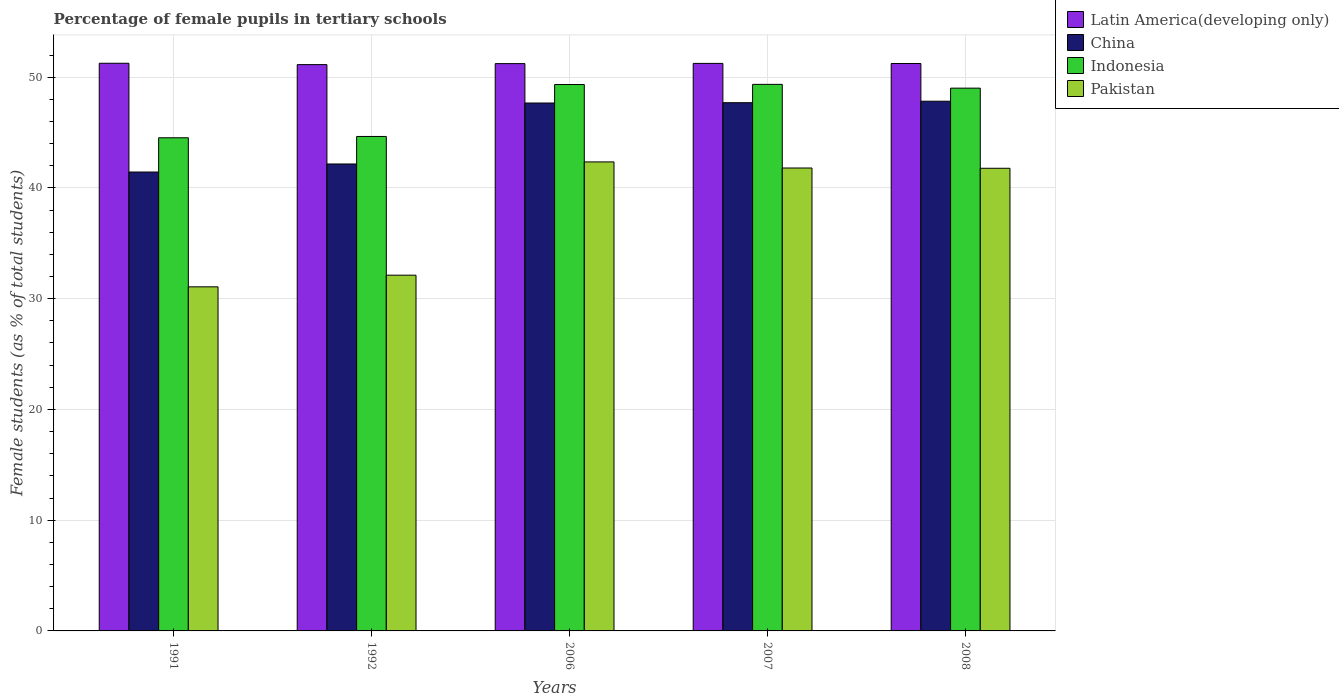How many different coloured bars are there?
Give a very brief answer. 4. How many bars are there on the 4th tick from the right?
Offer a very short reply. 4. What is the label of the 2nd group of bars from the left?
Provide a short and direct response. 1992. In how many cases, is the number of bars for a given year not equal to the number of legend labels?
Your answer should be very brief. 0. What is the percentage of female pupils in tertiary schools in Indonesia in 2008?
Offer a terse response. 49.01. Across all years, what is the maximum percentage of female pupils in tertiary schools in Indonesia?
Your answer should be compact. 49.35. Across all years, what is the minimum percentage of female pupils in tertiary schools in Indonesia?
Provide a short and direct response. 44.53. In which year was the percentage of female pupils in tertiary schools in China maximum?
Keep it short and to the point. 2008. What is the total percentage of female pupils in tertiary schools in Latin America(developing only) in the graph?
Your response must be concise. 256.1. What is the difference between the percentage of female pupils in tertiary schools in Pakistan in 1992 and that in 2007?
Offer a very short reply. -9.68. What is the difference between the percentage of female pupils in tertiary schools in China in 2007 and the percentage of female pupils in tertiary schools in Pakistan in 1991?
Ensure brevity in your answer.  16.63. What is the average percentage of female pupils in tertiary schools in Latin America(developing only) per year?
Provide a short and direct response. 51.22. In the year 1992, what is the difference between the percentage of female pupils in tertiary schools in China and percentage of female pupils in tertiary schools in Indonesia?
Your response must be concise. -2.49. What is the ratio of the percentage of female pupils in tertiary schools in Latin America(developing only) in 1991 to that in 1992?
Keep it short and to the point. 1. Is the percentage of female pupils in tertiary schools in Latin America(developing only) in 1991 less than that in 2006?
Offer a very short reply. No. Is the difference between the percentage of female pupils in tertiary schools in China in 1991 and 2006 greater than the difference between the percentage of female pupils in tertiary schools in Indonesia in 1991 and 2006?
Keep it short and to the point. No. What is the difference between the highest and the second highest percentage of female pupils in tertiary schools in Indonesia?
Provide a succinct answer. 0.01. What is the difference between the highest and the lowest percentage of female pupils in tertiary schools in Pakistan?
Keep it short and to the point. 11.28. Is the sum of the percentage of female pupils in tertiary schools in Pakistan in 1992 and 2008 greater than the maximum percentage of female pupils in tertiary schools in Indonesia across all years?
Keep it short and to the point. Yes. Are all the bars in the graph horizontal?
Your response must be concise. No. How many years are there in the graph?
Your answer should be very brief. 5. What is the difference between two consecutive major ticks on the Y-axis?
Provide a short and direct response. 10. Are the values on the major ticks of Y-axis written in scientific E-notation?
Provide a short and direct response. No. Does the graph contain grids?
Offer a terse response. Yes. How many legend labels are there?
Your answer should be compact. 4. What is the title of the graph?
Give a very brief answer. Percentage of female pupils in tertiary schools. Does "Central African Republic" appear as one of the legend labels in the graph?
Offer a very short reply. No. What is the label or title of the X-axis?
Provide a short and direct response. Years. What is the label or title of the Y-axis?
Offer a terse response. Female students (as % of total students). What is the Female students (as % of total students) of Latin America(developing only) in 1991?
Provide a succinct answer. 51.26. What is the Female students (as % of total students) of China in 1991?
Make the answer very short. 41.44. What is the Female students (as % of total students) in Indonesia in 1991?
Your answer should be very brief. 44.53. What is the Female students (as % of total students) in Pakistan in 1991?
Offer a terse response. 31.07. What is the Female students (as % of total students) of Latin America(developing only) in 1992?
Give a very brief answer. 51.13. What is the Female students (as % of total students) in China in 1992?
Offer a terse response. 42.16. What is the Female students (as % of total students) in Indonesia in 1992?
Offer a very short reply. 44.65. What is the Female students (as % of total students) of Pakistan in 1992?
Keep it short and to the point. 32.12. What is the Female students (as % of total students) in Latin America(developing only) in 2006?
Provide a succinct answer. 51.22. What is the Female students (as % of total students) of China in 2006?
Give a very brief answer. 47.67. What is the Female students (as % of total students) of Indonesia in 2006?
Keep it short and to the point. 49.34. What is the Female students (as % of total students) of Pakistan in 2006?
Provide a short and direct response. 42.35. What is the Female students (as % of total students) of Latin America(developing only) in 2007?
Provide a succinct answer. 51.24. What is the Female students (as % of total students) in China in 2007?
Ensure brevity in your answer.  47.7. What is the Female students (as % of total students) in Indonesia in 2007?
Ensure brevity in your answer.  49.35. What is the Female students (as % of total students) in Pakistan in 2007?
Your answer should be compact. 41.8. What is the Female students (as % of total students) of Latin America(developing only) in 2008?
Provide a succinct answer. 51.24. What is the Female students (as % of total students) in China in 2008?
Your answer should be very brief. 47.83. What is the Female students (as % of total students) of Indonesia in 2008?
Keep it short and to the point. 49.01. What is the Female students (as % of total students) in Pakistan in 2008?
Offer a very short reply. 41.78. Across all years, what is the maximum Female students (as % of total students) of Latin America(developing only)?
Provide a short and direct response. 51.26. Across all years, what is the maximum Female students (as % of total students) in China?
Offer a terse response. 47.83. Across all years, what is the maximum Female students (as % of total students) of Indonesia?
Offer a terse response. 49.35. Across all years, what is the maximum Female students (as % of total students) in Pakistan?
Provide a succinct answer. 42.35. Across all years, what is the minimum Female students (as % of total students) in Latin America(developing only)?
Keep it short and to the point. 51.13. Across all years, what is the minimum Female students (as % of total students) of China?
Your answer should be compact. 41.44. Across all years, what is the minimum Female students (as % of total students) of Indonesia?
Provide a succinct answer. 44.53. Across all years, what is the minimum Female students (as % of total students) in Pakistan?
Offer a very short reply. 31.07. What is the total Female students (as % of total students) of Latin America(developing only) in the graph?
Make the answer very short. 256.1. What is the total Female students (as % of total students) of China in the graph?
Your response must be concise. 226.79. What is the total Female students (as % of total students) of Indonesia in the graph?
Provide a succinct answer. 236.87. What is the total Female students (as % of total students) of Pakistan in the graph?
Your response must be concise. 189.11. What is the difference between the Female students (as % of total students) of Latin America(developing only) in 1991 and that in 1992?
Make the answer very short. 0.12. What is the difference between the Female students (as % of total students) of China in 1991 and that in 1992?
Give a very brief answer. -0.73. What is the difference between the Female students (as % of total students) in Indonesia in 1991 and that in 1992?
Your response must be concise. -0.12. What is the difference between the Female students (as % of total students) of Pakistan in 1991 and that in 1992?
Offer a terse response. -1.05. What is the difference between the Female students (as % of total students) of Latin America(developing only) in 1991 and that in 2006?
Offer a terse response. 0.03. What is the difference between the Female students (as % of total students) in China in 1991 and that in 2006?
Your answer should be very brief. -6.23. What is the difference between the Female students (as % of total students) of Indonesia in 1991 and that in 2006?
Your answer should be very brief. -4.81. What is the difference between the Female students (as % of total students) of Pakistan in 1991 and that in 2006?
Offer a very short reply. -11.28. What is the difference between the Female students (as % of total students) in Latin America(developing only) in 1991 and that in 2007?
Ensure brevity in your answer.  0.01. What is the difference between the Female students (as % of total students) in China in 1991 and that in 2007?
Give a very brief answer. -6.26. What is the difference between the Female students (as % of total students) in Indonesia in 1991 and that in 2007?
Keep it short and to the point. -4.82. What is the difference between the Female students (as % of total students) in Pakistan in 1991 and that in 2007?
Offer a very short reply. -10.73. What is the difference between the Female students (as % of total students) in Latin America(developing only) in 1991 and that in 2008?
Make the answer very short. 0.02. What is the difference between the Female students (as % of total students) of China in 1991 and that in 2008?
Offer a very short reply. -6.39. What is the difference between the Female students (as % of total students) in Indonesia in 1991 and that in 2008?
Offer a very short reply. -4.48. What is the difference between the Female students (as % of total students) in Pakistan in 1991 and that in 2008?
Provide a succinct answer. -10.71. What is the difference between the Female students (as % of total students) in Latin America(developing only) in 1992 and that in 2006?
Give a very brief answer. -0.09. What is the difference between the Female students (as % of total students) in China in 1992 and that in 2006?
Provide a short and direct response. -5.51. What is the difference between the Female students (as % of total students) of Indonesia in 1992 and that in 2006?
Offer a terse response. -4.69. What is the difference between the Female students (as % of total students) of Pakistan in 1992 and that in 2006?
Provide a short and direct response. -10.23. What is the difference between the Female students (as % of total students) of Latin America(developing only) in 1992 and that in 2007?
Offer a very short reply. -0.11. What is the difference between the Female students (as % of total students) of China in 1992 and that in 2007?
Offer a terse response. -5.53. What is the difference between the Female students (as % of total students) of Indonesia in 1992 and that in 2007?
Offer a very short reply. -4.7. What is the difference between the Female students (as % of total students) in Pakistan in 1992 and that in 2007?
Provide a short and direct response. -9.68. What is the difference between the Female students (as % of total students) in Latin America(developing only) in 1992 and that in 2008?
Give a very brief answer. -0.1. What is the difference between the Female students (as % of total students) of China in 1992 and that in 2008?
Give a very brief answer. -5.67. What is the difference between the Female students (as % of total students) in Indonesia in 1992 and that in 2008?
Give a very brief answer. -4.36. What is the difference between the Female students (as % of total students) of Pakistan in 1992 and that in 2008?
Offer a terse response. -9.65. What is the difference between the Female students (as % of total students) of Latin America(developing only) in 2006 and that in 2007?
Ensure brevity in your answer.  -0.02. What is the difference between the Female students (as % of total students) of China in 2006 and that in 2007?
Keep it short and to the point. -0.03. What is the difference between the Female students (as % of total students) in Indonesia in 2006 and that in 2007?
Offer a terse response. -0.01. What is the difference between the Female students (as % of total students) in Pakistan in 2006 and that in 2007?
Offer a terse response. 0.55. What is the difference between the Female students (as % of total students) of Latin America(developing only) in 2006 and that in 2008?
Keep it short and to the point. -0.01. What is the difference between the Female students (as % of total students) in China in 2006 and that in 2008?
Offer a very short reply. -0.16. What is the difference between the Female students (as % of total students) in Indonesia in 2006 and that in 2008?
Your answer should be very brief. 0.33. What is the difference between the Female students (as % of total students) in Pakistan in 2006 and that in 2008?
Ensure brevity in your answer.  0.57. What is the difference between the Female students (as % of total students) of Latin America(developing only) in 2007 and that in 2008?
Provide a short and direct response. 0.01. What is the difference between the Female students (as % of total students) of China in 2007 and that in 2008?
Offer a very short reply. -0.13. What is the difference between the Female students (as % of total students) in Indonesia in 2007 and that in 2008?
Provide a short and direct response. 0.34. What is the difference between the Female students (as % of total students) of Pakistan in 2007 and that in 2008?
Keep it short and to the point. 0.02. What is the difference between the Female students (as % of total students) of Latin America(developing only) in 1991 and the Female students (as % of total students) of China in 1992?
Provide a short and direct response. 9.09. What is the difference between the Female students (as % of total students) of Latin America(developing only) in 1991 and the Female students (as % of total students) of Indonesia in 1992?
Your answer should be compact. 6.61. What is the difference between the Female students (as % of total students) of Latin America(developing only) in 1991 and the Female students (as % of total students) of Pakistan in 1992?
Your answer should be very brief. 19.14. What is the difference between the Female students (as % of total students) in China in 1991 and the Female students (as % of total students) in Indonesia in 1992?
Ensure brevity in your answer.  -3.21. What is the difference between the Female students (as % of total students) of China in 1991 and the Female students (as % of total students) of Pakistan in 1992?
Provide a succinct answer. 9.31. What is the difference between the Female students (as % of total students) of Indonesia in 1991 and the Female students (as % of total students) of Pakistan in 1992?
Provide a short and direct response. 12.41. What is the difference between the Female students (as % of total students) in Latin America(developing only) in 1991 and the Female students (as % of total students) in China in 2006?
Provide a succinct answer. 3.59. What is the difference between the Female students (as % of total students) in Latin America(developing only) in 1991 and the Female students (as % of total students) in Indonesia in 2006?
Make the answer very short. 1.92. What is the difference between the Female students (as % of total students) of Latin America(developing only) in 1991 and the Female students (as % of total students) of Pakistan in 2006?
Ensure brevity in your answer.  8.91. What is the difference between the Female students (as % of total students) in China in 1991 and the Female students (as % of total students) in Indonesia in 2006?
Ensure brevity in your answer.  -7.9. What is the difference between the Female students (as % of total students) of China in 1991 and the Female students (as % of total students) of Pakistan in 2006?
Provide a short and direct response. -0.91. What is the difference between the Female students (as % of total students) of Indonesia in 1991 and the Female students (as % of total students) of Pakistan in 2006?
Provide a succinct answer. 2.18. What is the difference between the Female students (as % of total students) of Latin America(developing only) in 1991 and the Female students (as % of total students) of China in 2007?
Provide a succinct answer. 3.56. What is the difference between the Female students (as % of total students) in Latin America(developing only) in 1991 and the Female students (as % of total students) in Indonesia in 2007?
Ensure brevity in your answer.  1.91. What is the difference between the Female students (as % of total students) of Latin America(developing only) in 1991 and the Female students (as % of total students) of Pakistan in 2007?
Offer a terse response. 9.46. What is the difference between the Female students (as % of total students) of China in 1991 and the Female students (as % of total students) of Indonesia in 2007?
Your answer should be very brief. -7.91. What is the difference between the Female students (as % of total students) in China in 1991 and the Female students (as % of total students) in Pakistan in 2007?
Your answer should be compact. -0.36. What is the difference between the Female students (as % of total students) of Indonesia in 1991 and the Female students (as % of total students) of Pakistan in 2007?
Your answer should be very brief. 2.73. What is the difference between the Female students (as % of total students) of Latin America(developing only) in 1991 and the Female students (as % of total students) of China in 2008?
Provide a succinct answer. 3.43. What is the difference between the Female students (as % of total students) in Latin America(developing only) in 1991 and the Female students (as % of total students) in Indonesia in 2008?
Give a very brief answer. 2.25. What is the difference between the Female students (as % of total students) in Latin America(developing only) in 1991 and the Female students (as % of total students) in Pakistan in 2008?
Ensure brevity in your answer.  9.48. What is the difference between the Female students (as % of total students) of China in 1991 and the Female students (as % of total students) of Indonesia in 2008?
Ensure brevity in your answer.  -7.57. What is the difference between the Female students (as % of total students) of China in 1991 and the Female students (as % of total students) of Pakistan in 2008?
Offer a terse response. -0.34. What is the difference between the Female students (as % of total students) of Indonesia in 1991 and the Female students (as % of total students) of Pakistan in 2008?
Make the answer very short. 2.75. What is the difference between the Female students (as % of total students) in Latin America(developing only) in 1992 and the Female students (as % of total students) in China in 2006?
Ensure brevity in your answer.  3.47. What is the difference between the Female students (as % of total students) of Latin America(developing only) in 1992 and the Female students (as % of total students) of Indonesia in 2006?
Make the answer very short. 1.8. What is the difference between the Female students (as % of total students) in Latin America(developing only) in 1992 and the Female students (as % of total students) in Pakistan in 2006?
Ensure brevity in your answer.  8.78. What is the difference between the Female students (as % of total students) of China in 1992 and the Female students (as % of total students) of Indonesia in 2006?
Provide a short and direct response. -7.17. What is the difference between the Female students (as % of total students) in China in 1992 and the Female students (as % of total students) in Pakistan in 2006?
Give a very brief answer. -0.19. What is the difference between the Female students (as % of total students) of Indonesia in 1992 and the Female students (as % of total students) of Pakistan in 2006?
Your response must be concise. 2.3. What is the difference between the Female students (as % of total students) of Latin America(developing only) in 1992 and the Female students (as % of total students) of China in 2007?
Make the answer very short. 3.44. What is the difference between the Female students (as % of total students) in Latin America(developing only) in 1992 and the Female students (as % of total students) in Indonesia in 2007?
Your answer should be very brief. 1.78. What is the difference between the Female students (as % of total students) in Latin America(developing only) in 1992 and the Female students (as % of total students) in Pakistan in 2007?
Your response must be concise. 9.34. What is the difference between the Female students (as % of total students) of China in 1992 and the Female students (as % of total students) of Indonesia in 2007?
Keep it short and to the point. -7.19. What is the difference between the Female students (as % of total students) in China in 1992 and the Female students (as % of total students) in Pakistan in 2007?
Keep it short and to the point. 0.36. What is the difference between the Female students (as % of total students) of Indonesia in 1992 and the Female students (as % of total students) of Pakistan in 2007?
Make the answer very short. 2.85. What is the difference between the Female students (as % of total students) in Latin America(developing only) in 1992 and the Female students (as % of total students) in China in 2008?
Your answer should be compact. 3.3. What is the difference between the Female students (as % of total students) in Latin America(developing only) in 1992 and the Female students (as % of total students) in Indonesia in 2008?
Provide a succinct answer. 2.12. What is the difference between the Female students (as % of total students) in Latin America(developing only) in 1992 and the Female students (as % of total students) in Pakistan in 2008?
Offer a terse response. 9.36. What is the difference between the Female students (as % of total students) of China in 1992 and the Female students (as % of total students) of Indonesia in 2008?
Make the answer very short. -6.85. What is the difference between the Female students (as % of total students) in China in 1992 and the Female students (as % of total students) in Pakistan in 2008?
Ensure brevity in your answer.  0.39. What is the difference between the Female students (as % of total students) in Indonesia in 1992 and the Female students (as % of total students) in Pakistan in 2008?
Make the answer very short. 2.87. What is the difference between the Female students (as % of total students) in Latin America(developing only) in 2006 and the Female students (as % of total students) in China in 2007?
Your answer should be very brief. 3.53. What is the difference between the Female students (as % of total students) in Latin America(developing only) in 2006 and the Female students (as % of total students) in Indonesia in 2007?
Make the answer very short. 1.87. What is the difference between the Female students (as % of total students) in Latin America(developing only) in 2006 and the Female students (as % of total students) in Pakistan in 2007?
Keep it short and to the point. 9.43. What is the difference between the Female students (as % of total students) of China in 2006 and the Female students (as % of total students) of Indonesia in 2007?
Make the answer very short. -1.68. What is the difference between the Female students (as % of total students) in China in 2006 and the Female students (as % of total students) in Pakistan in 2007?
Keep it short and to the point. 5.87. What is the difference between the Female students (as % of total students) of Indonesia in 2006 and the Female students (as % of total students) of Pakistan in 2007?
Ensure brevity in your answer.  7.54. What is the difference between the Female students (as % of total students) of Latin America(developing only) in 2006 and the Female students (as % of total students) of China in 2008?
Your response must be concise. 3.39. What is the difference between the Female students (as % of total students) of Latin America(developing only) in 2006 and the Female students (as % of total students) of Indonesia in 2008?
Offer a very short reply. 2.21. What is the difference between the Female students (as % of total students) of Latin America(developing only) in 2006 and the Female students (as % of total students) of Pakistan in 2008?
Offer a very short reply. 9.45. What is the difference between the Female students (as % of total students) in China in 2006 and the Female students (as % of total students) in Indonesia in 2008?
Provide a succinct answer. -1.34. What is the difference between the Female students (as % of total students) in China in 2006 and the Female students (as % of total students) in Pakistan in 2008?
Provide a succinct answer. 5.89. What is the difference between the Female students (as % of total students) in Indonesia in 2006 and the Female students (as % of total students) in Pakistan in 2008?
Keep it short and to the point. 7.56. What is the difference between the Female students (as % of total students) of Latin America(developing only) in 2007 and the Female students (as % of total students) of China in 2008?
Your answer should be very brief. 3.41. What is the difference between the Female students (as % of total students) in Latin America(developing only) in 2007 and the Female students (as % of total students) in Indonesia in 2008?
Give a very brief answer. 2.24. What is the difference between the Female students (as % of total students) in Latin America(developing only) in 2007 and the Female students (as % of total students) in Pakistan in 2008?
Keep it short and to the point. 9.47. What is the difference between the Female students (as % of total students) in China in 2007 and the Female students (as % of total students) in Indonesia in 2008?
Offer a terse response. -1.31. What is the difference between the Female students (as % of total students) in China in 2007 and the Female students (as % of total students) in Pakistan in 2008?
Your answer should be compact. 5.92. What is the difference between the Female students (as % of total students) of Indonesia in 2007 and the Female students (as % of total students) of Pakistan in 2008?
Your answer should be compact. 7.58. What is the average Female students (as % of total students) of Latin America(developing only) per year?
Offer a terse response. 51.22. What is the average Female students (as % of total students) in China per year?
Your answer should be compact. 45.36. What is the average Female students (as % of total students) of Indonesia per year?
Provide a succinct answer. 47.37. What is the average Female students (as % of total students) in Pakistan per year?
Your answer should be compact. 37.82. In the year 1991, what is the difference between the Female students (as % of total students) in Latin America(developing only) and Female students (as % of total students) in China?
Your answer should be very brief. 9.82. In the year 1991, what is the difference between the Female students (as % of total students) of Latin America(developing only) and Female students (as % of total students) of Indonesia?
Give a very brief answer. 6.73. In the year 1991, what is the difference between the Female students (as % of total students) in Latin America(developing only) and Female students (as % of total students) in Pakistan?
Make the answer very short. 20.19. In the year 1991, what is the difference between the Female students (as % of total students) of China and Female students (as % of total students) of Indonesia?
Your answer should be compact. -3.09. In the year 1991, what is the difference between the Female students (as % of total students) of China and Female students (as % of total students) of Pakistan?
Make the answer very short. 10.37. In the year 1991, what is the difference between the Female students (as % of total students) of Indonesia and Female students (as % of total students) of Pakistan?
Your response must be concise. 13.46. In the year 1992, what is the difference between the Female students (as % of total students) of Latin America(developing only) and Female students (as % of total students) of China?
Give a very brief answer. 8.97. In the year 1992, what is the difference between the Female students (as % of total students) in Latin America(developing only) and Female students (as % of total students) in Indonesia?
Provide a short and direct response. 6.49. In the year 1992, what is the difference between the Female students (as % of total students) of Latin America(developing only) and Female students (as % of total students) of Pakistan?
Make the answer very short. 19.01. In the year 1992, what is the difference between the Female students (as % of total students) in China and Female students (as % of total students) in Indonesia?
Your answer should be compact. -2.49. In the year 1992, what is the difference between the Female students (as % of total students) in China and Female students (as % of total students) in Pakistan?
Provide a short and direct response. 10.04. In the year 1992, what is the difference between the Female students (as % of total students) in Indonesia and Female students (as % of total students) in Pakistan?
Your response must be concise. 12.53. In the year 2006, what is the difference between the Female students (as % of total students) in Latin America(developing only) and Female students (as % of total students) in China?
Give a very brief answer. 3.56. In the year 2006, what is the difference between the Female students (as % of total students) of Latin America(developing only) and Female students (as % of total students) of Indonesia?
Provide a succinct answer. 1.89. In the year 2006, what is the difference between the Female students (as % of total students) in Latin America(developing only) and Female students (as % of total students) in Pakistan?
Your answer should be compact. 8.87. In the year 2006, what is the difference between the Female students (as % of total students) of China and Female students (as % of total students) of Indonesia?
Provide a succinct answer. -1.67. In the year 2006, what is the difference between the Female students (as % of total students) in China and Female students (as % of total students) in Pakistan?
Make the answer very short. 5.32. In the year 2006, what is the difference between the Female students (as % of total students) of Indonesia and Female students (as % of total students) of Pakistan?
Offer a very short reply. 6.99. In the year 2007, what is the difference between the Female students (as % of total students) in Latin America(developing only) and Female students (as % of total students) in China?
Your response must be concise. 3.55. In the year 2007, what is the difference between the Female students (as % of total students) in Latin America(developing only) and Female students (as % of total students) in Indonesia?
Your answer should be very brief. 1.89. In the year 2007, what is the difference between the Female students (as % of total students) in Latin America(developing only) and Female students (as % of total students) in Pakistan?
Give a very brief answer. 9.45. In the year 2007, what is the difference between the Female students (as % of total students) in China and Female students (as % of total students) in Indonesia?
Keep it short and to the point. -1.66. In the year 2007, what is the difference between the Female students (as % of total students) in China and Female students (as % of total students) in Pakistan?
Provide a succinct answer. 5.9. In the year 2007, what is the difference between the Female students (as % of total students) in Indonesia and Female students (as % of total students) in Pakistan?
Provide a short and direct response. 7.55. In the year 2008, what is the difference between the Female students (as % of total students) of Latin America(developing only) and Female students (as % of total students) of China?
Your answer should be very brief. 3.41. In the year 2008, what is the difference between the Female students (as % of total students) in Latin America(developing only) and Female students (as % of total students) in Indonesia?
Ensure brevity in your answer.  2.23. In the year 2008, what is the difference between the Female students (as % of total students) in Latin America(developing only) and Female students (as % of total students) in Pakistan?
Keep it short and to the point. 9.46. In the year 2008, what is the difference between the Female students (as % of total students) in China and Female students (as % of total students) in Indonesia?
Offer a very short reply. -1.18. In the year 2008, what is the difference between the Female students (as % of total students) of China and Female students (as % of total students) of Pakistan?
Provide a succinct answer. 6.05. In the year 2008, what is the difference between the Female students (as % of total students) of Indonesia and Female students (as % of total students) of Pakistan?
Your answer should be very brief. 7.23. What is the ratio of the Female students (as % of total students) in Latin America(developing only) in 1991 to that in 1992?
Keep it short and to the point. 1. What is the ratio of the Female students (as % of total students) in China in 1991 to that in 1992?
Give a very brief answer. 0.98. What is the ratio of the Female students (as % of total students) in Indonesia in 1991 to that in 1992?
Offer a terse response. 1. What is the ratio of the Female students (as % of total students) in Pakistan in 1991 to that in 1992?
Offer a very short reply. 0.97. What is the ratio of the Female students (as % of total students) of Latin America(developing only) in 1991 to that in 2006?
Make the answer very short. 1. What is the ratio of the Female students (as % of total students) in China in 1991 to that in 2006?
Ensure brevity in your answer.  0.87. What is the ratio of the Female students (as % of total students) in Indonesia in 1991 to that in 2006?
Keep it short and to the point. 0.9. What is the ratio of the Female students (as % of total students) of Pakistan in 1991 to that in 2006?
Provide a short and direct response. 0.73. What is the ratio of the Female students (as % of total students) in Latin America(developing only) in 1991 to that in 2007?
Your answer should be very brief. 1. What is the ratio of the Female students (as % of total students) of China in 1991 to that in 2007?
Make the answer very short. 0.87. What is the ratio of the Female students (as % of total students) in Indonesia in 1991 to that in 2007?
Your response must be concise. 0.9. What is the ratio of the Female students (as % of total students) in Pakistan in 1991 to that in 2007?
Provide a succinct answer. 0.74. What is the ratio of the Female students (as % of total students) in Latin America(developing only) in 1991 to that in 2008?
Make the answer very short. 1. What is the ratio of the Female students (as % of total students) in China in 1991 to that in 2008?
Offer a terse response. 0.87. What is the ratio of the Female students (as % of total students) in Indonesia in 1991 to that in 2008?
Your answer should be very brief. 0.91. What is the ratio of the Female students (as % of total students) of Pakistan in 1991 to that in 2008?
Ensure brevity in your answer.  0.74. What is the ratio of the Female students (as % of total students) in Latin America(developing only) in 1992 to that in 2006?
Make the answer very short. 1. What is the ratio of the Female students (as % of total students) of China in 1992 to that in 2006?
Your answer should be compact. 0.88. What is the ratio of the Female students (as % of total students) in Indonesia in 1992 to that in 2006?
Offer a terse response. 0.91. What is the ratio of the Female students (as % of total students) in Pakistan in 1992 to that in 2006?
Your answer should be very brief. 0.76. What is the ratio of the Female students (as % of total students) of China in 1992 to that in 2007?
Make the answer very short. 0.88. What is the ratio of the Female students (as % of total students) of Indonesia in 1992 to that in 2007?
Offer a terse response. 0.9. What is the ratio of the Female students (as % of total students) of Pakistan in 1992 to that in 2007?
Provide a succinct answer. 0.77. What is the ratio of the Female students (as % of total students) of China in 1992 to that in 2008?
Offer a very short reply. 0.88. What is the ratio of the Female students (as % of total students) in Indonesia in 1992 to that in 2008?
Offer a very short reply. 0.91. What is the ratio of the Female students (as % of total students) of Pakistan in 1992 to that in 2008?
Make the answer very short. 0.77. What is the ratio of the Female students (as % of total students) of Pakistan in 2006 to that in 2007?
Ensure brevity in your answer.  1.01. What is the ratio of the Female students (as % of total students) of Indonesia in 2006 to that in 2008?
Offer a terse response. 1.01. What is the ratio of the Female students (as % of total students) in Pakistan in 2006 to that in 2008?
Your response must be concise. 1.01. What is the ratio of the Female students (as % of total students) of Indonesia in 2007 to that in 2008?
Offer a terse response. 1.01. What is the ratio of the Female students (as % of total students) of Pakistan in 2007 to that in 2008?
Your response must be concise. 1. What is the difference between the highest and the second highest Female students (as % of total students) of Latin America(developing only)?
Give a very brief answer. 0.01. What is the difference between the highest and the second highest Female students (as % of total students) in China?
Give a very brief answer. 0.13. What is the difference between the highest and the second highest Female students (as % of total students) of Indonesia?
Make the answer very short. 0.01. What is the difference between the highest and the second highest Female students (as % of total students) of Pakistan?
Your answer should be very brief. 0.55. What is the difference between the highest and the lowest Female students (as % of total students) in Latin America(developing only)?
Offer a terse response. 0.12. What is the difference between the highest and the lowest Female students (as % of total students) of China?
Ensure brevity in your answer.  6.39. What is the difference between the highest and the lowest Female students (as % of total students) in Indonesia?
Offer a terse response. 4.82. What is the difference between the highest and the lowest Female students (as % of total students) of Pakistan?
Provide a succinct answer. 11.28. 